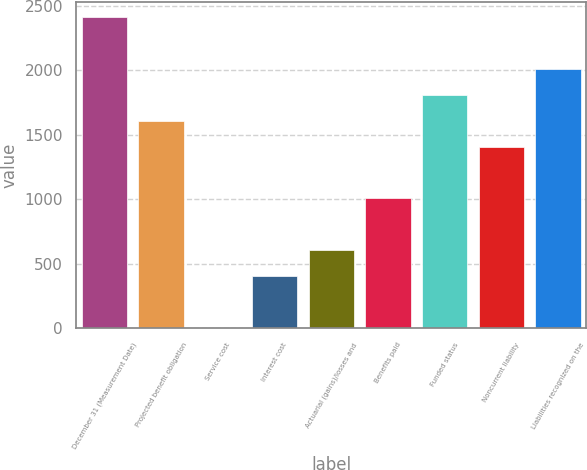Convert chart. <chart><loc_0><loc_0><loc_500><loc_500><bar_chart><fcel>December 31 (Measurement Date)<fcel>Projected benefit obligation<fcel>Service cost<fcel>Interest cost<fcel>Actuarial (gains)/losses and<fcel>Benefits paid<fcel>Funded status<fcel>Noncurrent liability<fcel>Liabilities recognized on the<nl><fcel>2413.4<fcel>1610.6<fcel>5<fcel>406.4<fcel>607.1<fcel>1008.5<fcel>1811.3<fcel>1409.9<fcel>2012<nl></chart> 